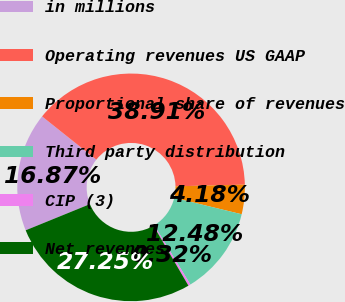Convert chart. <chart><loc_0><loc_0><loc_500><loc_500><pie_chart><fcel>in millions<fcel>Operating revenues US GAAP<fcel>Proportional share of revenues<fcel>Third party distribution<fcel>CIP (3)<fcel>Net revenues<nl><fcel>16.87%<fcel>38.91%<fcel>4.18%<fcel>12.48%<fcel>0.32%<fcel>27.25%<nl></chart> 